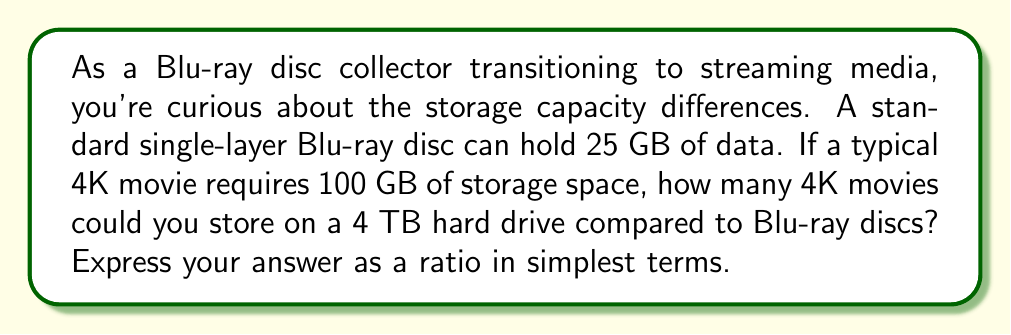Show me your answer to this math problem. Let's approach this step-by-step:

1) First, let's convert the hard drive capacity to GB:
   $$ 4 \text{ TB} = 4 \times 1000 \text{ GB} = 4000 \text{ GB} $$

2) Now, let's calculate how many 4K movies can be stored on the 4 TB hard drive:
   $$ \text{Number of movies on HDD} = \frac{4000 \text{ GB}}{100 \text{ GB per movie}} = 40 \text{ movies} $$

3) Next, let's calculate how many Blu-ray discs would be needed for one 4K movie:
   $$ \text{Blu-rays per movie} = \frac{100 \text{ GB per movie}}{25 \text{ GB per Blu-ray}} = 4 \text{ Blu-rays} $$

4) So, 40 movies would require:
   $$ 40 \text{ movies} \times 4 \text{ Blu-rays per movie} = 160 \text{ Blu-rays} $$

5) Now we can express this as a ratio:
   $$ \frac{\text{Movies on HDD}}{\text{Equivalent number of Blu-rays}} = \frac{40}{160} $$

6) Simplify this ratio:
   $$ \frac{40}{160} = \frac{1}{4} $$

This means that for every 1 movie you can store on the hard drive, you would need 4 Blu-ray discs to store the same content.
Answer: $1:4$ 